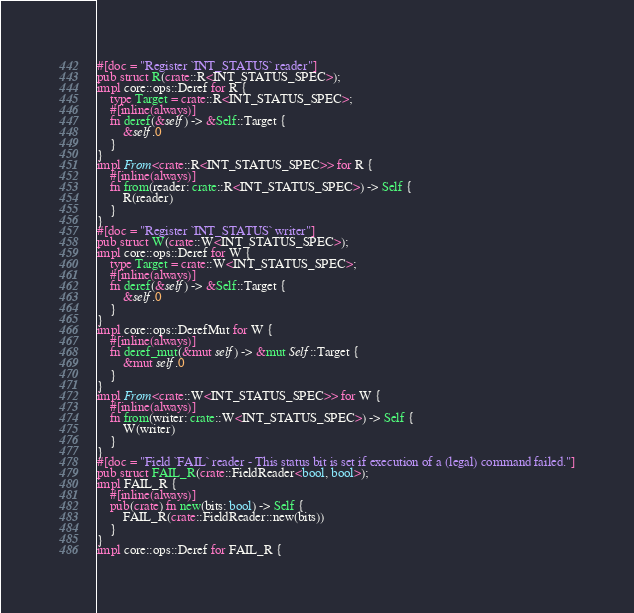<code> <loc_0><loc_0><loc_500><loc_500><_Rust_>#[doc = "Register `INT_STATUS` reader"]
pub struct R(crate::R<INT_STATUS_SPEC>);
impl core::ops::Deref for R {
    type Target = crate::R<INT_STATUS_SPEC>;
    #[inline(always)]
    fn deref(&self) -> &Self::Target {
        &self.0
    }
}
impl From<crate::R<INT_STATUS_SPEC>> for R {
    #[inline(always)]
    fn from(reader: crate::R<INT_STATUS_SPEC>) -> Self {
        R(reader)
    }
}
#[doc = "Register `INT_STATUS` writer"]
pub struct W(crate::W<INT_STATUS_SPEC>);
impl core::ops::Deref for W {
    type Target = crate::W<INT_STATUS_SPEC>;
    #[inline(always)]
    fn deref(&self) -> &Self::Target {
        &self.0
    }
}
impl core::ops::DerefMut for W {
    #[inline(always)]
    fn deref_mut(&mut self) -> &mut Self::Target {
        &mut self.0
    }
}
impl From<crate::W<INT_STATUS_SPEC>> for W {
    #[inline(always)]
    fn from(writer: crate::W<INT_STATUS_SPEC>) -> Self {
        W(writer)
    }
}
#[doc = "Field `FAIL` reader - This status bit is set if execution of a (legal) command failed."]
pub struct FAIL_R(crate::FieldReader<bool, bool>);
impl FAIL_R {
    #[inline(always)]
    pub(crate) fn new(bits: bool) -> Self {
        FAIL_R(crate::FieldReader::new(bits))
    }
}
impl core::ops::Deref for FAIL_R {</code> 